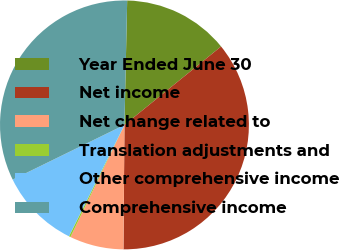Convert chart. <chart><loc_0><loc_0><loc_500><loc_500><pie_chart><fcel>Year Ended June 30<fcel>Net income<fcel>Net change related to<fcel>Translation adjustments and<fcel>Other comprehensive income<fcel>Comprehensive income<nl><fcel>13.8%<fcel>35.98%<fcel>7.01%<fcel>0.22%<fcel>10.4%<fcel>32.59%<nl></chart> 